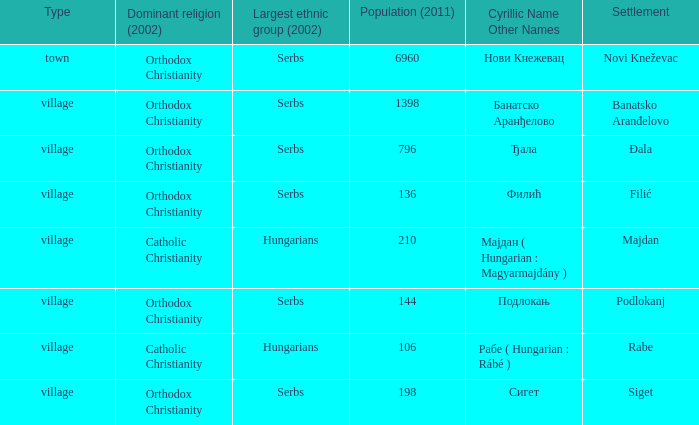What type of settlement is rabe? Village. 